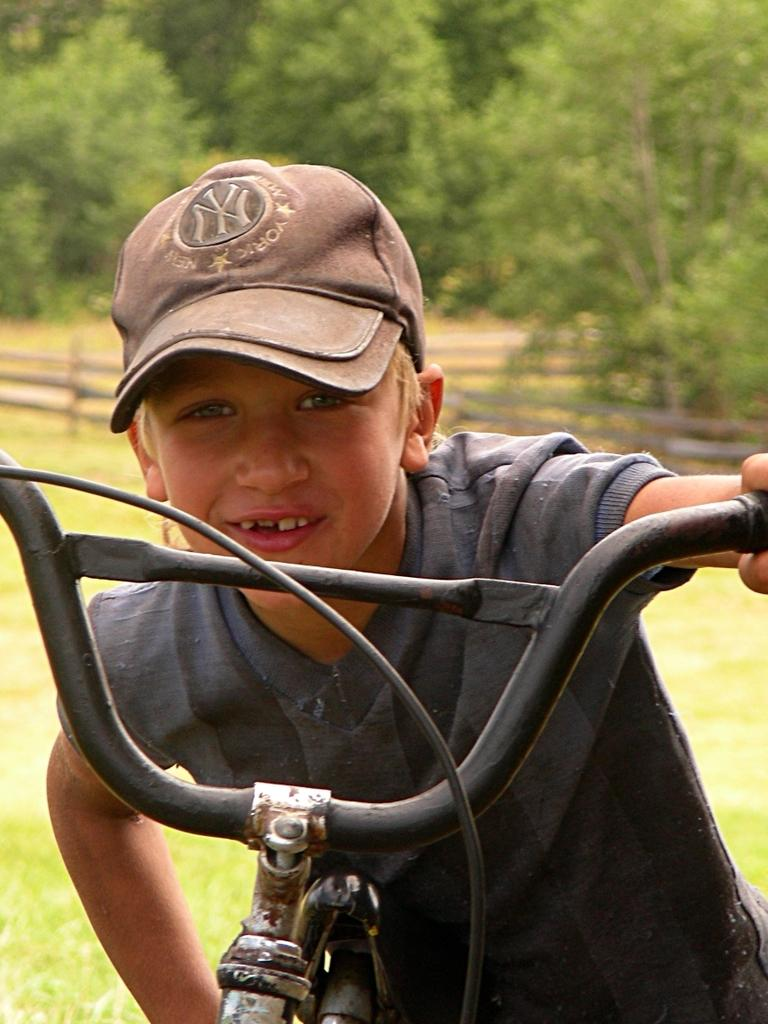Who is the main subject in the image? There is a boy in the image. What is the boy wearing on his head? The boy is wearing a cap. What is the boy holding in the image? The boy is holding a bicycle. What can be seen in the background of the image? There are trees and a fence in the background of the image. What type of hen can be seen in the image? There is no hen present in the image. Is the weather in the image hot or cold? The provided facts do not mention the weather or temperature, so it cannot be determined from the image. 